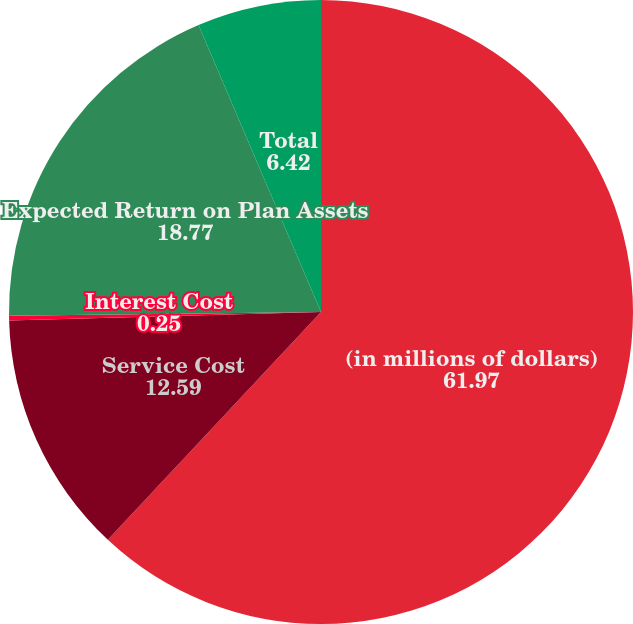<chart> <loc_0><loc_0><loc_500><loc_500><pie_chart><fcel>(in millions of dollars)<fcel>Service Cost<fcel>Interest Cost<fcel>Expected Return on Plan Assets<fcel>Total<nl><fcel>61.97%<fcel>12.59%<fcel>0.25%<fcel>18.77%<fcel>6.42%<nl></chart> 